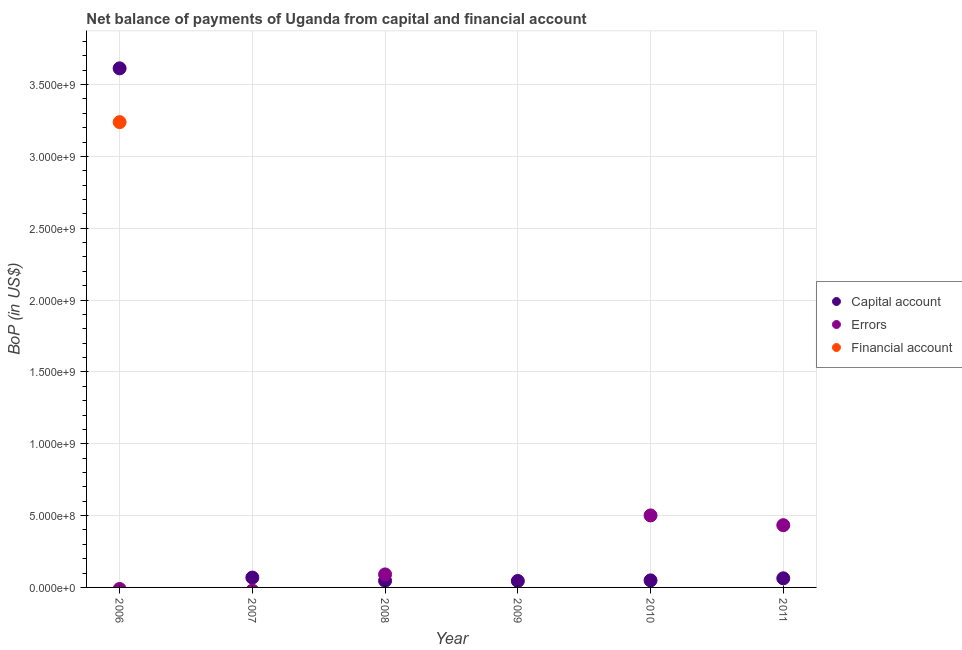How many different coloured dotlines are there?
Provide a short and direct response. 3. Is the number of dotlines equal to the number of legend labels?
Provide a succinct answer. No. What is the amount of financial account in 2008?
Provide a short and direct response. 0. Across all years, what is the maximum amount of errors?
Keep it short and to the point. 5.01e+08. Across all years, what is the minimum amount of net capital account?
Your answer should be compact. 4.49e+07. What is the total amount of errors in the graph?
Offer a terse response. 1.03e+09. What is the difference between the amount of net capital account in 2009 and that in 2011?
Make the answer very short. -1.85e+07. What is the difference between the amount of errors in 2006 and the amount of net capital account in 2009?
Your answer should be compact. -4.49e+07. What is the average amount of errors per year?
Your answer should be very brief. 1.71e+08. In the year 2008, what is the difference between the amount of net capital account and amount of errors?
Ensure brevity in your answer.  -4.42e+07. Is the amount of net capital account in 2008 less than that in 2009?
Your answer should be compact. No. What is the difference between the highest and the second highest amount of net capital account?
Your answer should be compact. 3.54e+09. What is the difference between the highest and the lowest amount of net capital account?
Your answer should be compact. 3.57e+09. In how many years, is the amount of financial account greater than the average amount of financial account taken over all years?
Your response must be concise. 1. Is the sum of the amount of net capital account in 2006 and 2007 greater than the maximum amount of financial account across all years?
Your answer should be compact. Yes. Does the amount of financial account monotonically increase over the years?
Your answer should be compact. No. How many years are there in the graph?
Provide a succinct answer. 6. What is the difference between two consecutive major ticks on the Y-axis?
Offer a very short reply. 5.00e+08. Are the values on the major ticks of Y-axis written in scientific E-notation?
Provide a succinct answer. Yes. Does the graph contain grids?
Give a very brief answer. Yes. Where does the legend appear in the graph?
Your answer should be compact. Center right. How are the legend labels stacked?
Provide a short and direct response. Vertical. What is the title of the graph?
Offer a very short reply. Net balance of payments of Uganda from capital and financial account. What is the label or title of the X-axis?
Your answer should be compact. Year. What is the label or title of the Y-axis?
Offer a terse response. BoP (in US$). What is the BoP (in US$) of Capital account in 2006?
Give a very brief answer. 3.61e+09. What is the BoP (in US$) of Financial account in 2006?
Provide a succinct answer. 3.24e+09. What is the BoP (in US$) in Capital account in 2007?
Provide a short and direct response. 6.86e+07. What is the BoP (in US$) in Financial account in 2007?
Your answer should be compact. 0. What is the BoP (in US$) in Capital account in 2008?
Your answer should be very brief. 4.65e+07. What is the BoP (in US$) of Errors in 2008?
Your answer should be very brief. 9.07e+07. What is the BoP (in US$) in Capital account in 2009?
Your answer should be very brief. 4.49e+07. What is the BoP (in US$) in Errors in 2009?
Provide a succinct answer. 0. What is the BoP (in US$) of Capital account in 2010?
Offer a terse response. 4.91e+07. What is the BoP (in US$) in Errors in 2010?
Offer a terse response. 5.01e+08. What is the BoP (in US$) in Financial account in 2010?
Ensure brevity in your answer.  0. What is the BoP (in US$) in Capital account in 2011?
Your answer should be compact. 6.34e+07. What is the BoP (in US$) in Errors in 2011?
Provide a succinct answer. 4.33e+08. Across all years, what is the maximum BoP (in US$) in Capital account?
Give a very brief answer. 3.61e+09. Across all years, what is the maximum BoP (in US$) in Errors?
Your response must be concise. 5.01e+08. Across all years, what is the maximum BoP (in US$) of Financial account?
Provide a succinct answer. 3.24e+09. Across all years, what is the minimum BoP (in US$) in Capital account?
Your answer should be very brief. 4.49e+07. What is the total BoP (in US$) of Capital account in the graph?
Provide a short and direct response. 3.89e+09. What is the total BoP (in US$) in Errors in the graph?
Provide a succinct answer. 1.03e+09. What is the total BoP (in US$) in Financial account in the graph?
Provide a short and direct response. 3.24e+09. What is the difference between the BoP (in US$) of Capital account in 2006 and that in 2007?
Provide a short and direct response. 3.54e+09. What is the difference between the BoP (in US$) of Capital account in 2006 and that in 2008?
Make the answer very short. 3.57e+09. What is the difference between the BoP (in US$) in Capital account in 2006 and that in 2009?
Your answer should be compact. 3.57e+09. What is the difference between the BoP (in US$) of Capital account in 2006 and that in 2010?
Offer a terse response. 3.56e+09. What is the difference between the BoP (in US$) in Capital account in 2006 and that in 2011?
Your answer should be compact. 3.55e+09. What is the difference between the BoP (in US$) of Capital account in 2007 and that in 2008?
Your answer should be very brief. 2.21e+07. What is the difference between the BoP (in US$) in Capital account in 2007 and that in 2009?
Offer a very short reply. 2.37e+07. What is the difference between the BoP (in US$) of Capital account in 2007 and that in 2010?
Keep it short and to the point. 1.95e+07. What is the difference between the BoP (in US$) in Capital account in 2007 and that in 2011?
Offer a very short reply. 5.24e+06. What is the difference between the BoP (in US$) of Capital account in 2008 and that in 2009?
Offer a very short reply. 1.62e+06. What is the difference between the BoP (in US$) of Capital account in 2008 and that in 2010?
Offer a terse response. -2.56e+06. What is the difference between the BoP (in US$) of Errors in 2008 and that in 2010?
Provide a short and direct response. -4.11e+08. What is the difference between the BoP (in US$) of Capital account in 2008 and that in 2011?
Provide a succinct answer. -1.69e+07. What is the difference between the BoP (in US$) in Errors in 2008 and that in 2011?
Your answer should be very brief. -3.43e+08. What is the difference between the BoP (in US$) of Capital account in 2009 and that in 2010?
Your response must be concise. -4.18e+06. What is the difference between the BoP (in US$) of Capital account in 2009 and that in 2011?
Offer a terse response. -1.85e+07. What is the difference between the BoP (in US$) of Capital account in 2010 and that in 2011?
Provide a short and direct response. -1.43e+07. What is the difference between the BoP (in US$) in Errors in 2010 and that in 2011?
Your answer should be compact. 6.79e+07. What is the difference between the BoP (in US$) of Capital account in 2006 and the BoP (in US$) of Errors in 2008?
Offer a terse response. 3.52e+09. What is the difference between the BoP (in US$) in Capital account in 2006 and the BoP (in US$) in Errors in 2010?
Offer a very short reply. 3.11e+09. What is the difference between the BoP (in US$) in Capital account in 2006 and the BoP (in US$) in Errors in 2011?
Keep it short and to the point. 3.18e+09. What is the difference between the BoP (in US$) of Capital account in 2007 and the BoP (in US$) of Errors in 2008?
Your response must be concise. -2.21e+07. What is the difference between the BoP (in US$) in Capital account in 2007 and the BoP (in US$) in Errors in 2010?
Keep it short and to the point. -4.33e+08. What is the difference between the BoP (in US$) in Capital account in 2007 and the BoP (in US$) in Errors in 2011?
Your answer should be compact. -3.65e+08. What is the difference between the BoP (in US$) in Capital account in 2008 and the BoP (in US$) in Errors in 2010?
Offer a very short reply. -4.55e+08. What is the difference between the BoP (in US$) of Capital account in 2008 and the BoP (in US$) of Errors in 2011?
Give a very brief answer. -3.87e+08. What is the difference between the BoP (in US$) in Capital account in 2009 and the BoP (in US$) in Errors in 2010?
Make the answer very short. -4.56e+08. What is the difference between the BoP (in US$) of Capital account in 2009 and the BoP (in US$) of Errors in 2011?
Provide a succinct answer. -3.88e+08. What is the difference between the BoP (in US$) in Capital account in 2010 and the BoP (in US$) in Errors in 2011?
Make the answer very short. -3.84e+08. What is the average BoP (in US$) of Capital account per year?
Keep it short and to the point. 6.48e+08. What is the average BoP (in US$) in Errors per year?
Make the answer very short. 1.71e+08. What is the average BoP (in US$) of Financial account per year?
Offer a very short reply. 5.40e+08. In the year 2006, what is the difference between the BoP (in US$) of Capital account and BoP (in US$) of Financial account?
Ensure brevity in your answer.  3.74e+08. In the year 2008, what is the difference between the BoP (in US$) in Capital account and BoP (in US$) in Errors?
Offer a very short reply. -4.42e+07. In the year 2010, what is the difference between the BoP (in US$) in Capital account and BoP (in US$) in Errors?
Offer a terse response. -4.52e+08. In the year 2011, what is the difference between the BoP (in US$) in Capital account and BoP (in US$) in Errors?
Your answer should be very brief. -3.70e+08. What is the ratio of the BoP (in US$) in Capital account in 2006 to that in 2007?
Keep it short and to the point. 52.66. What is the ratio of the BoP (in US$) of Capital account in 2006 to that in 2008?
Your response must be concise. 77.69. What is the ratio of the BoP (in US$) of Capital account in 2006 to that in 2009?
Provide a succinct answer. 80.5. What is the ratio of the BoP (in US$) in Capital account in 2006 to that in 2010?
Ensure brevity in your answer.  73.64. What is the ratio of the BoP (in US$) in Capital account in 2006 to that in 2011?
Offer a terse response. 57.02. What is the ratio of the BoP (in US$) in Capital account in 2007 to that in 2008?
Give a very brief answer. 1.48. What is the ratio of the BoP (in US$) of Capital account in 2007 to that in 2009?
Provide a short and direct response. 1.53. What is the ratio of the BoP (in US$) in Capital account in 2007 to that in 2010?
Make the answer very short. 1.4. What is the ratio of the BoP (in US$) of Capital account in 2007 to that in 2011?
Offer a terse response. 1.08. What is the ratio of the BoP (in US$) in Capital account in 2008 to that in 2009?
Your answer should be very brief. 1.04. What is the ratio of the BoP (in US$) in Capital account in 2008 to that in 2010?
Give a very brief answer. 0.95. What is the ratio of the BoP (in US$) in Errors in 2008 to that in 2010?
Ensure brevity in your answer.  0.18. What is the ratio of the BoP (in US$) in Capital account in 2008 to that in 2011?
Offer a very short reply. 0.73. What is the ratio of the BoP (in US$) in Errors in 2008 to that in 2011?
Keep it short and to the point. 0.21. What is the ratio of the BoP (in US$) in Capital account in 2009 to that in 2010?
Keep it short and to the point. 0.91. What is the ratio of the BoP (in US$) of Capital account in 2009 to that in 2011?
Offer a very short reply. 0.71. What is the ratio of the BoP (in US$) of Capital account in 2010 to that in 2011?
Offer a very short reply. 0.77. What is the ratio of the BoP (in US$) in Errors in 2010 to that in 2011?
Your response must be concise. 1.16. What is the difference between the highest and the second highest BoP (in US$) in Capital account?
Give a very brief answer. 3.54e+09. What is the difference between the highest and the second highest BoP (in US$) of Errors?
Make the answer very short. 6.79e+07. What is the difference between the highest and the lowest BoP (in US$) in Capital account?
Provide a succinct answer. 3.57e+09. What is the difference between the highest and the lowest BoP (in US$) of Errors?
Your answer should be very brief. 5.01e+08. What is the difference between the highest and the lowest BoP (in US$) of Financial account?
Your answer should be compact. 3.24e+09. 